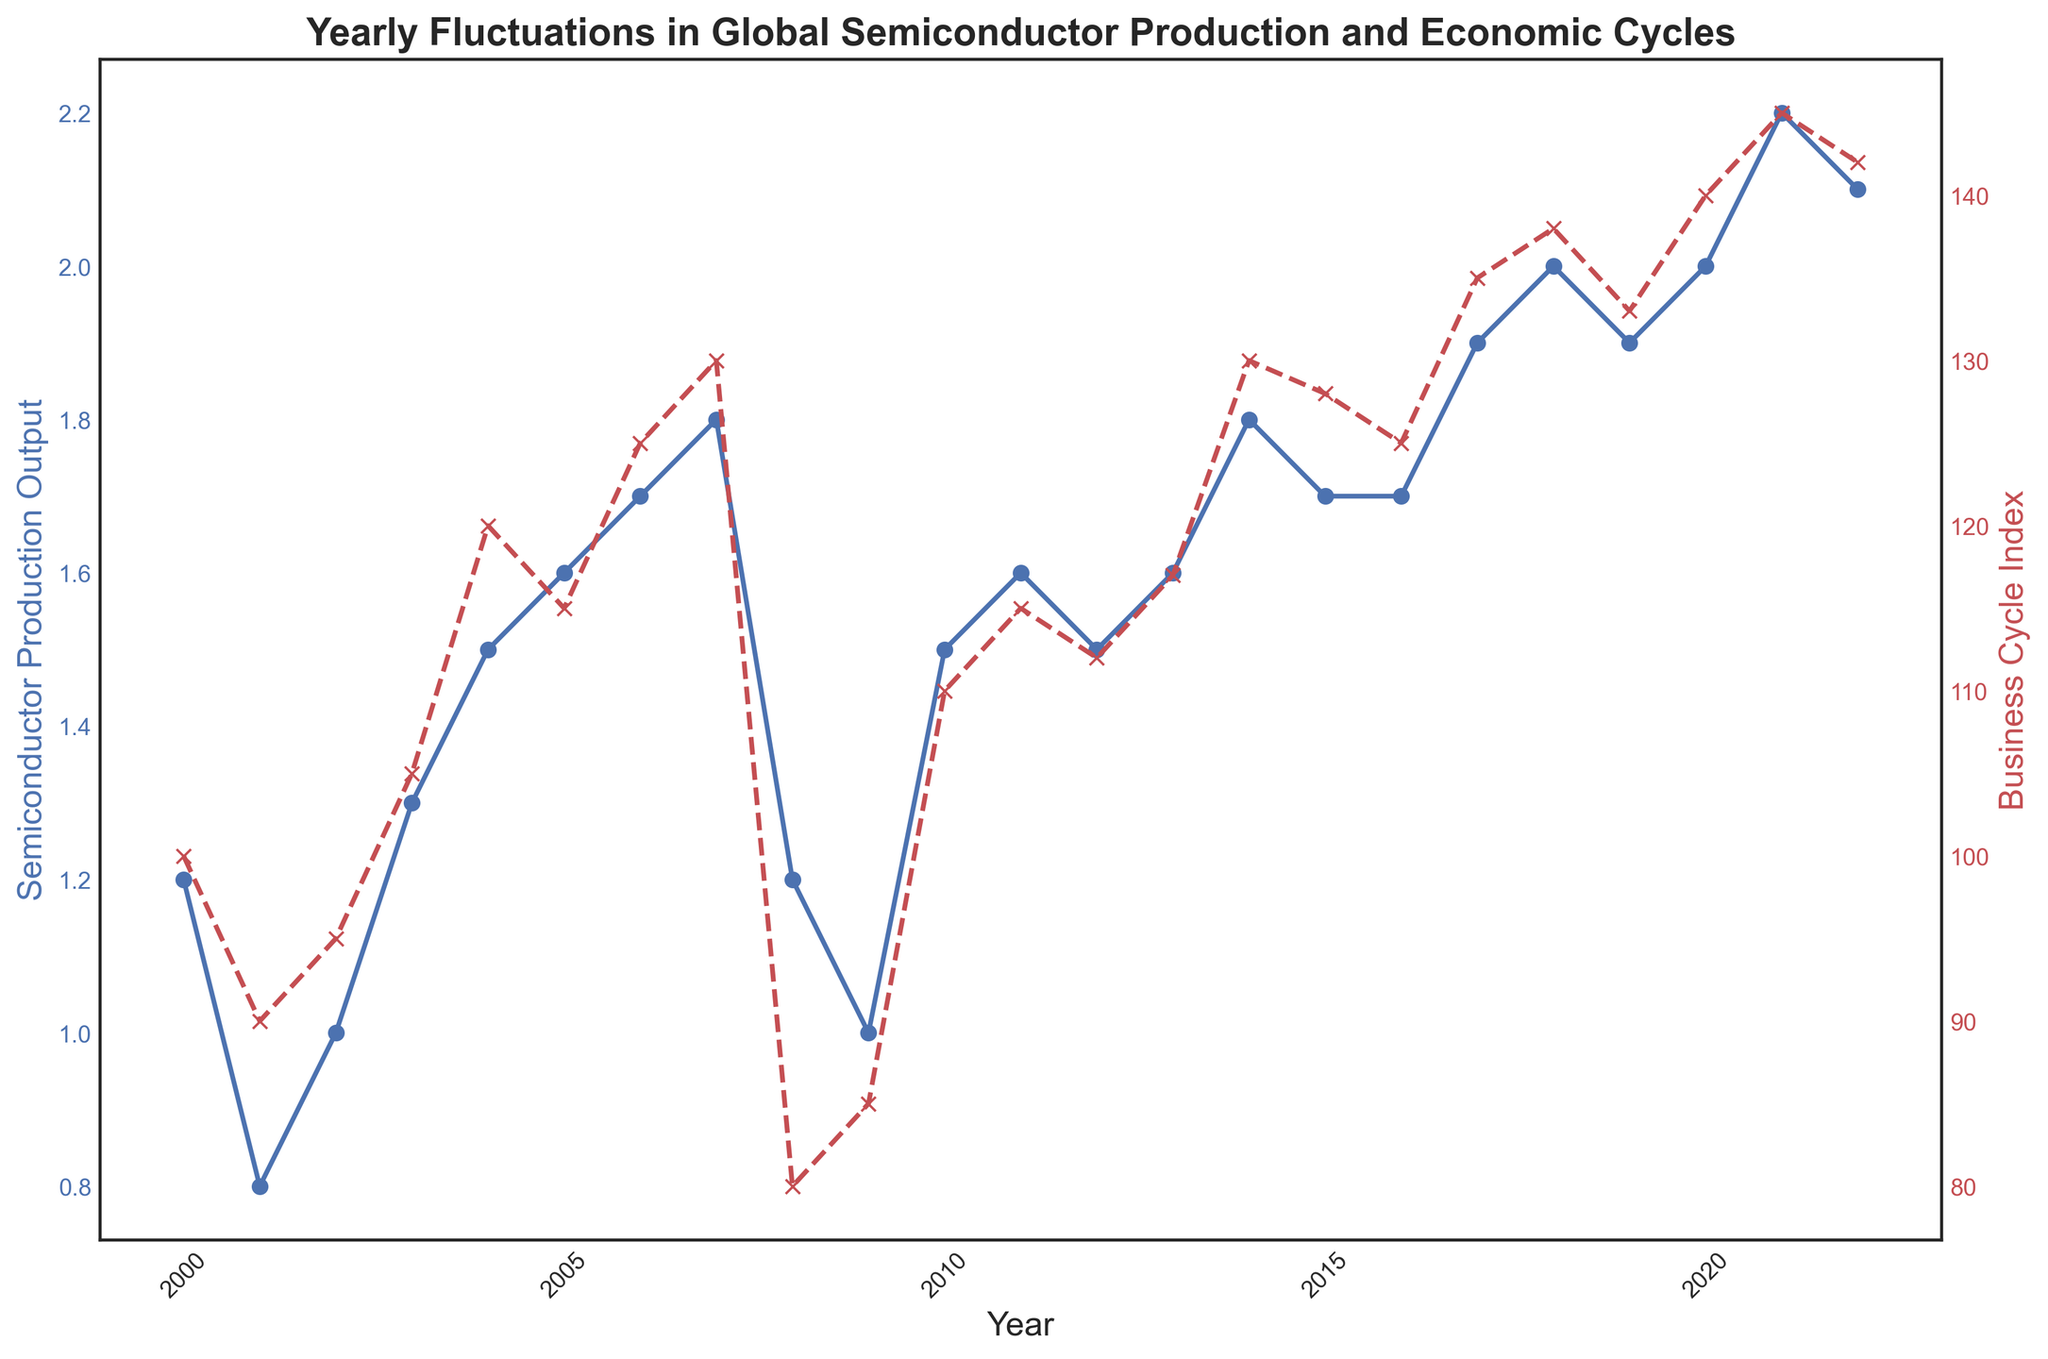What's the trend of the Semiconductor Production Output from 2000 to 2022? The line representing the Semiconductor Production Output shows an overall increasing trend with some fluctuations. Initially, from 2000 to 2001, it decreased, then it showed an overall increasing trend with intermittent drops, especially around 2008-2009 and 2015-2016.
Answer: Increasing When did the Business Cycle Index hit its lowest point? By observing the red dashed line representing the Business Cycle Index, we see it reached its lowest point in 2008.
Answer: 2008 Compare the Semiconductor Production Output in 2000 and 2022. Which year had a higher output? In 2000, the Semiconductor Production Output was lower compared to 2022. The blue line shows it increasing from 1.2 in 2000 to 2.1 in 2022.
Answer: 2022 What is the overall correlation between the Semiconductor Production Output and the Business Cycle Index? By visually inspecting both the blue line (Semiconductor Production Output) and the red dashed line (Business Cycle Index), they generally move in the same direction, indicating a positive correlation. When the Business Cycle Index increases, the Semiconductor Production Output often increases as well.
Answer: Positive correlation How did the global Semiconductor Production Output change from 2007 to 2008, and what might be the potential reason based on the Business Cycle Index? The Semiconductor Production Output decreased significantly from 1.8 in 2007 to 1.2 in 2008. The Business Cycle Index also dropped substantially from 130 in 2007 to 80 in 2008, suggesting an economic downturn might have influenced this decrease.
Answer: Decreased What was the difference in the Business Cycle Index between 2008 and 2009? The Business Cycle Index was 80 in 2008 and then increased to 85 in 2009, so the difference is 85 - 80 = 5.
Answer: 5 If the Semiconductor Production Output was averaged over the period from 2010 to 2015, what would it be? The Semiconductor Production Output values from 2010 to 2015 are 1.5, 1.6, 1.5, 1.6, 1.8, and 1.7. The average is (1.5 + 1.6 + 1.5 + 1.6 + 1.8 + 1.7) / 6 = 9.7 / 6 ≈ 1.62.
Answer: 1.62 How did the Semiconductor Production Output change during the 2008-2009 global financial crisis? The Semiconductor Production Output dropped from 1.8 in 2007 to 1.2 in 2008 and remained lower at 1.0 in 2009, highlighting a significant reduction during the global financial crisis.
Answer: Dropped What are the peak years for the Business Cycle Index, and how does it compare with the Semiconductor Production Output in those years? The peak year for the Business Cycle Index is 2021 at 145. In 2021, the Semiconductor Production Output was 2.2, its highest value as well. This shows both peak simultaneously in terms of their respective values indicating a strong positive correlation.
Answer: 2021 In which years did the Semiconductor Production Output remain constant, and what were the corresponding Business Cycle Index values in those years? The Semiconductor Production Output remained constant in 2016 and 2019 at 1.7 and 1.9, respectively. The corresponding Business Cycle Index values were 125 in 2016 and 133 in 2019.
Answer: 2016 and 2019 